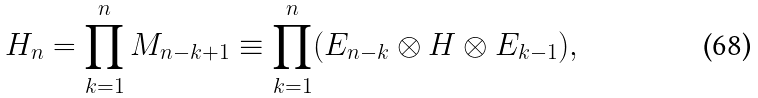Convert formula to latex. <formula><loc_0><loc_0><loc_500><loc_500>H _ { n } = \prod ^ { n } _ { k = 1 } M _ { n - k + 1 } \equiv \prod ^ { n } _ { k = 1 } ( E _ { n - k } \otimes H \otimes E _ { k - 1 } ) ,</formula> 